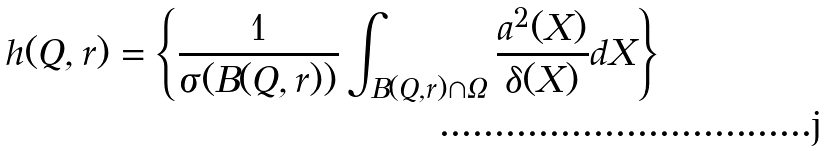<formula> <loc_0><loc_0><loc_500><loc_500>h ( Q , r ) = \left \{ \frac { 1 } { \sigma ( B ( Q , r ) ) } \int _ { B ( Q , r ) \cap \Omega } \frac { a ^ { 2 } ( X ) } { \delta ( X ) } d X \right \}</formula> 